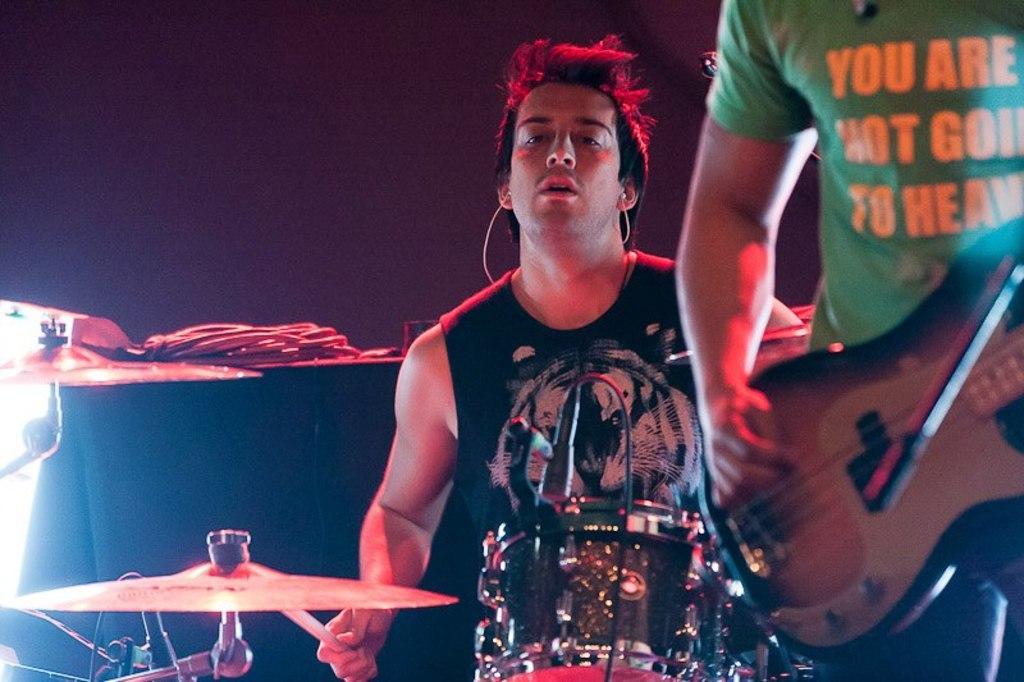Please provide a concise description of this image. In this image we can see two people playing musical instruments. 